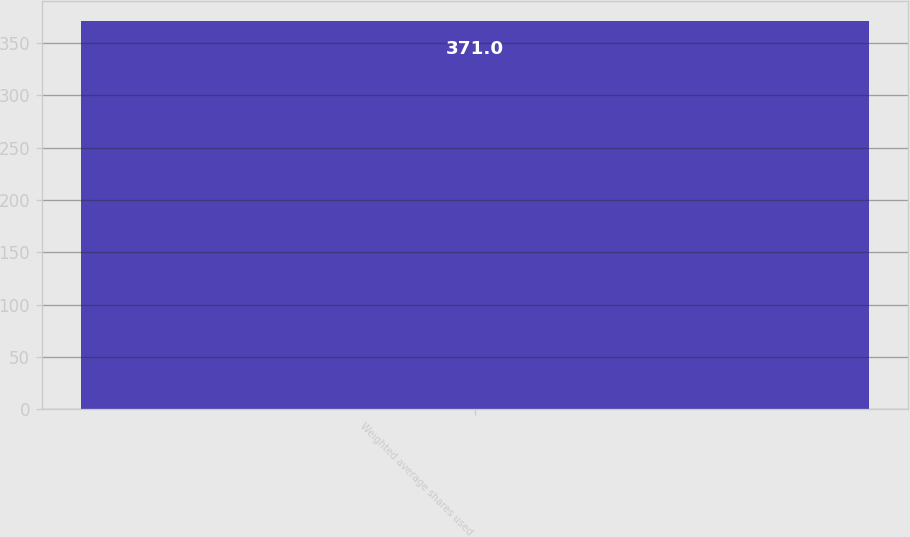<chart> <loc_0><loc_0><loc_500><loc_500><bar_chart><fcel>Weighted average shares used<nl><fcel>371<nl></chart> 